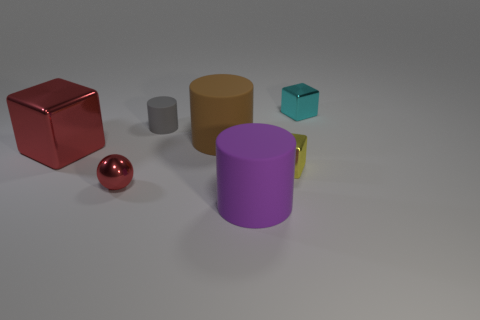Add 3 cyan metallic cubes. How many objects exist? 10 Subtract all gray matte cylinders. How many cylinders are left? 2 Subtract all cylinders. How many objects are left? 4 Subtract all brown spheres. Subtract all brown blocks. How many spheres are left? 1 Subtract all big red metallic balls. Subtract all large red shiny objects. How many objects are left? 6 Add 1 brown matte cylinders. How many brown matte cylinders are left? 2 Add 7 big gray shiny balls. How many big gray shiny balls exist? 7 Subtract all red cubes. How many cubes are left? 2 Subtract 1 red spheres. How many objects are left? 6 Subtract 2 cylinders. How many cylinders are left? 1 